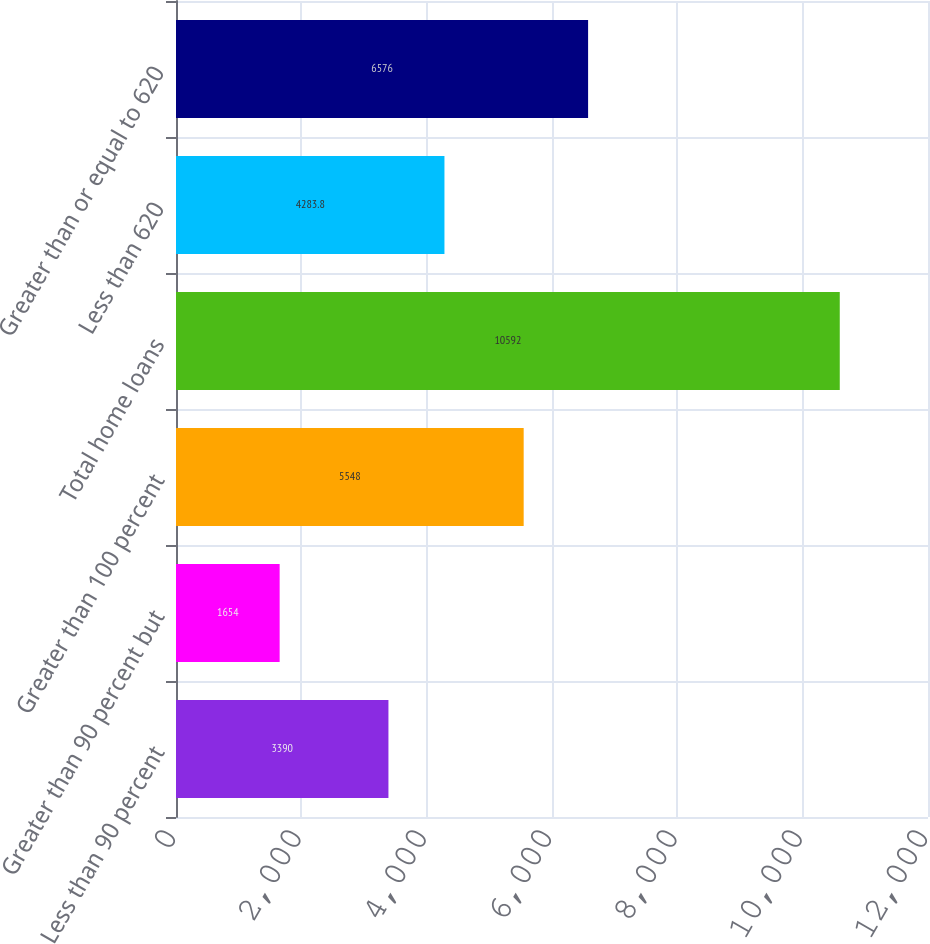<chart> <loc_0><loc_0><loc_500><loc_500><bar_chart><fcel>Less than 90 percent<fcel>Greater than 90 percent but<fcel>Greater than 100 percent<fcel>Total home loans<fcel>Less than 620<fcel>Greater than or equal to 620<nl><fcel>3390<fcel>1654<fcel>5548<fcel>10592<fcel>4283.8<fcel>6576<nl></chart> 